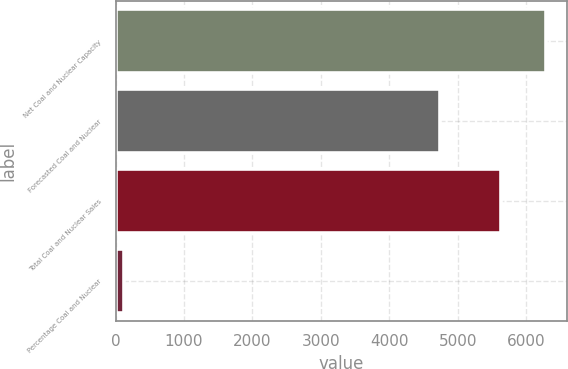Convert chart. <chart><loc_0><loc_0><loc_500><loc_500><bar_chart><fcel>Net Coal and Nuclear Capacity<fcel>Forecasted Coal and Nuclear<fcel>Total Coal and Nuclear Sales<fcel>Percentage Coal and Nuclear<nl><fcel>6290<fcel>4739<fcel>5629<fcel>119<nl></chart> 